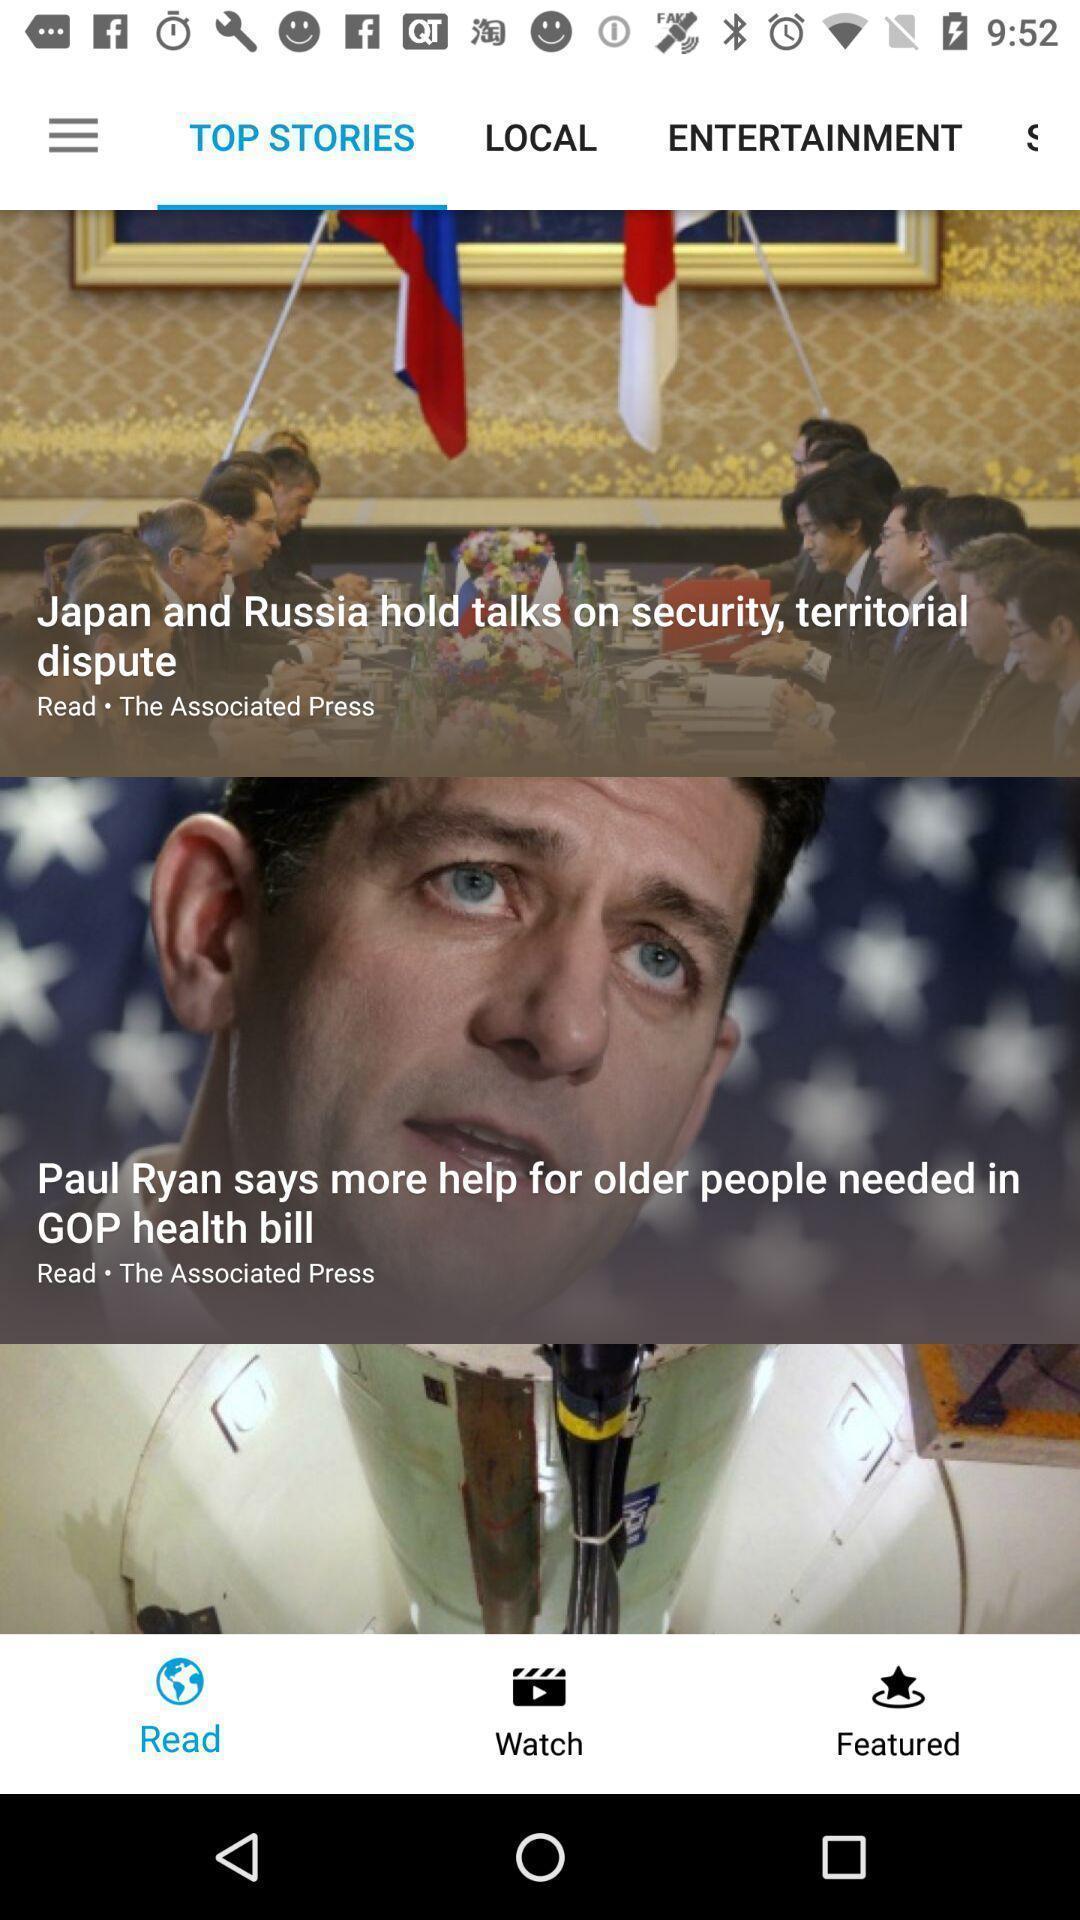Please provide a description for this image. Screen page displaying an articles with various options. 